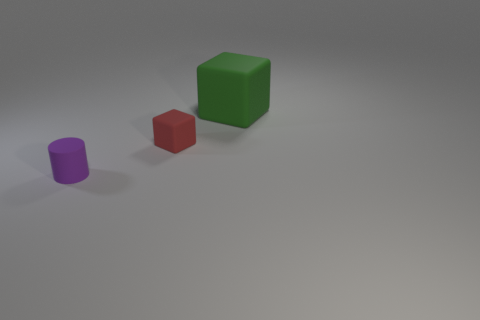Add 1 small things. How many objects exist? 4 Subtract all cylinders. How many objects are left? 2 Add 3 purple balls. How many purple balls exist? 3 Subtract 0 brown spheres. How many objects are left? 3 Subtract all small purple things. Subtract all green blocks. How many objects are left? 1 Add 1 small red objects. How many small red objects are left? 2 